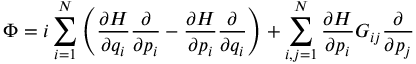Convert formula to latex. <formula><loc_0><loc_0><loc_500><loc_500>\Phi = i \sum _ { i = 1 } ^ { N } \left ( { \frac { \partial H } { \partial q _ { i } } } { \frac { \partial } { \partial p _ { i } } } - { \frac { \partial H } { \partial p _ { i } } } { \frac { \partial } { \partial q _ { i } } } \right ) + \sum _ { i , j = 1 } ^ { N } { \frac { \partial H } { \partial p _ { i } } } G _ { i j } { \frac { \partial } { \partial p _ { j } } }</formula> 